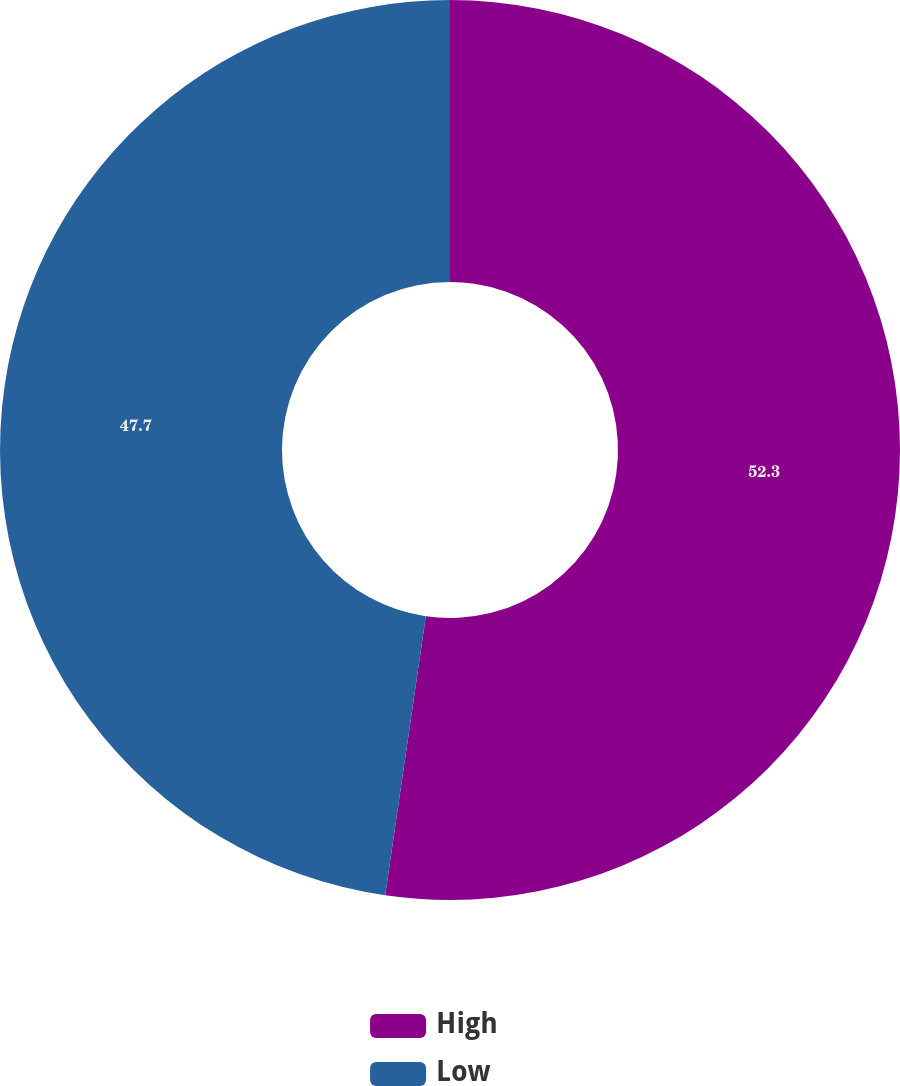Convert chart. <chart><loc_0><loc_0><loc_500><loc_500><pie_chart><fcel>High<fcel>Low<nl><fcel>52.3%<fcel>47.7%<nl></chart> 